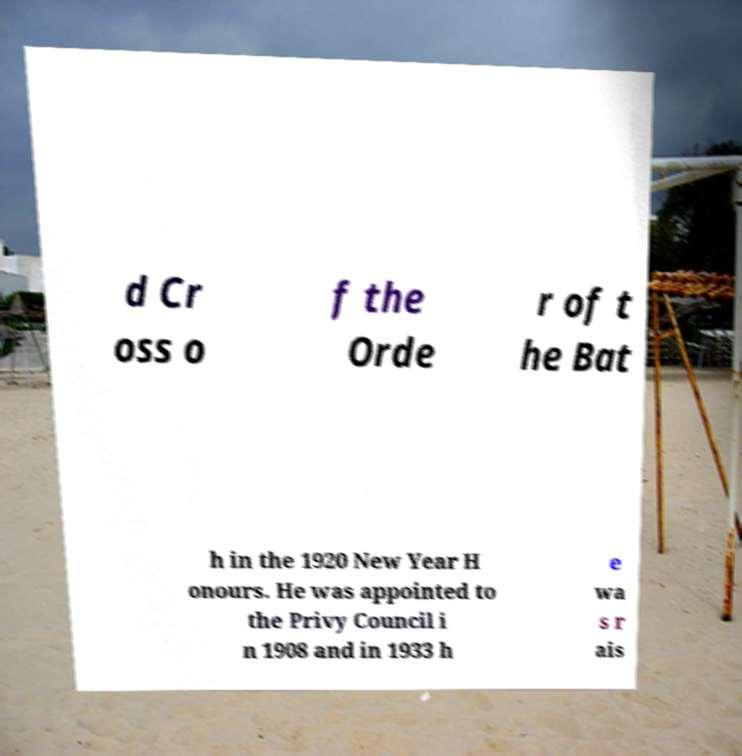Can you accurately transcribe the text from the provided image for me? d Cr oss o f the Orde r of t he Bat h in the 1920 New Year H onours. He was appointed to the Privy Council i n 1908 and in 1933 h e wa s r ais 